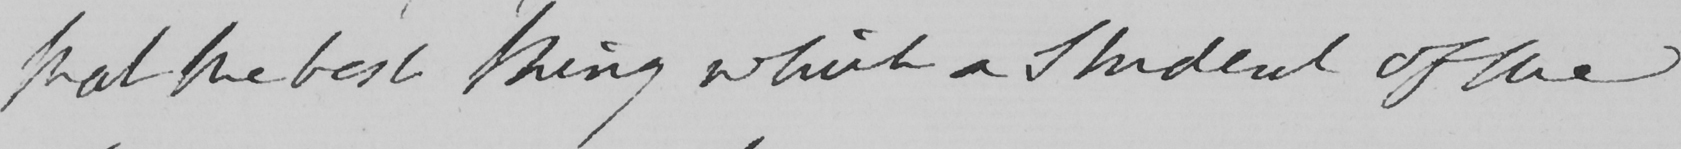What is written in this line of handwriting? that the best thing which a Student of the 